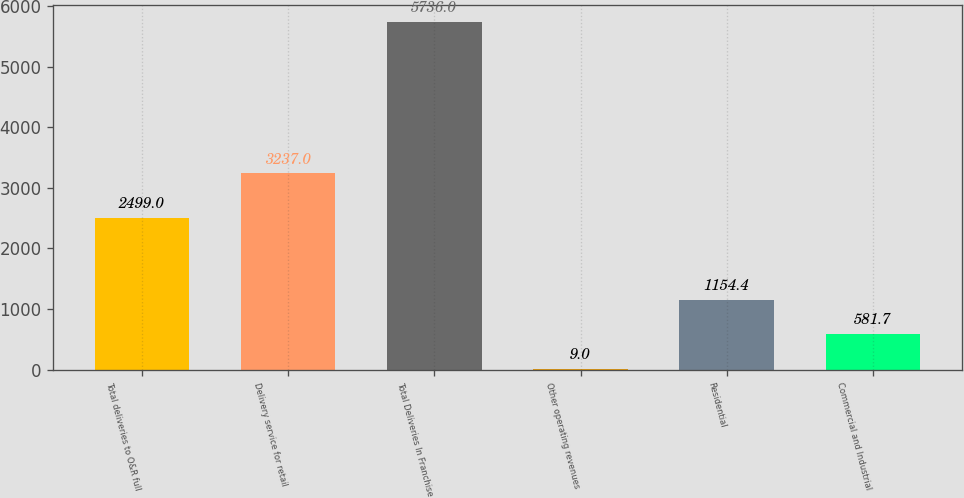<chart> <loc_0><loc_0><loc_500><loc_500><bar_chart><fcel>Total deliveries to O&R full<fcel>Delivery service for retail<fcel>Total Deliveries In Franchise<fcel>Other operating revenues<fcel>Residential<fcel>Commercial and Industrial<nl><fcel>2499<fcel>3237<fcel>5736<fcel>9<fcel>1154.4<fcel>581.7<nl></chart> 